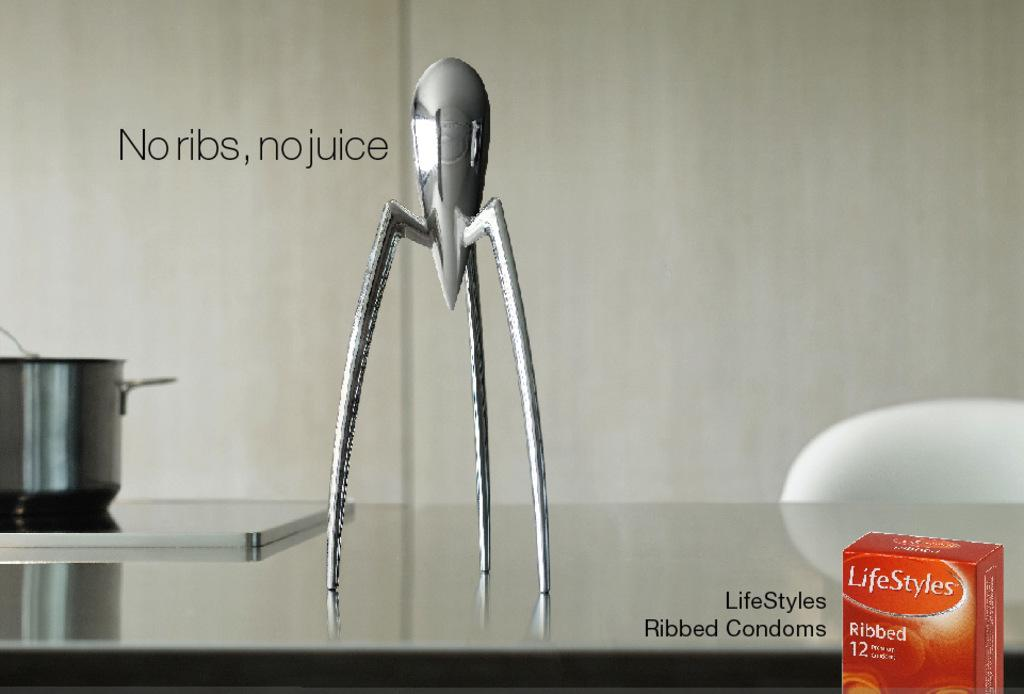<image>
Offer a succinct explanation of the picture presented. Ad for Lifestyles condoms that says "No ribs, no juice". 